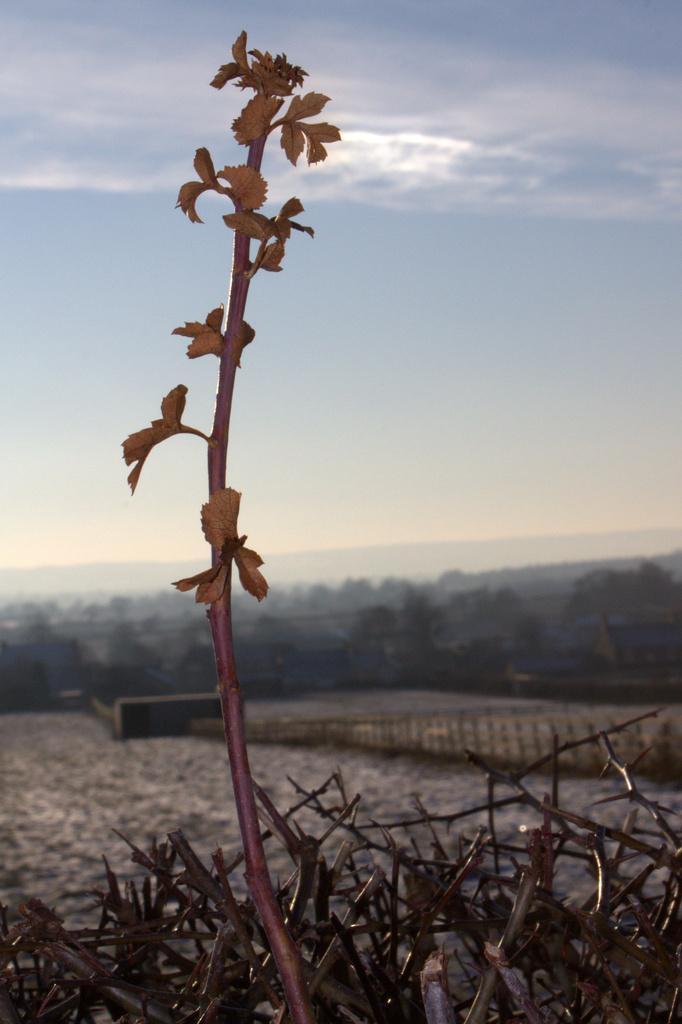How would you summarize this image in a sentence or two? In this picture we see trees and a plant and I see a blue cloudy Sky. 